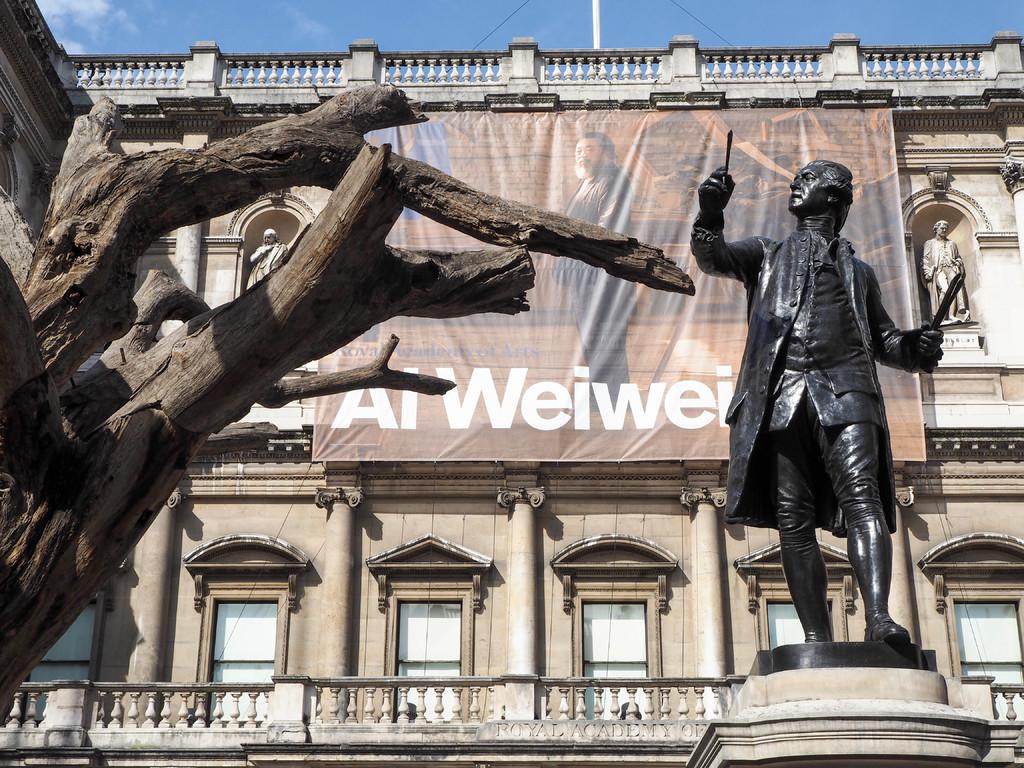What is the first letter of the second word in white?
Ensure brevity in your answer.  W. 